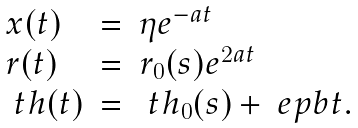<formula> <loc_0><loc_0><loc_500><loc_500>\begin{array} { l l l } x ( t ) & = & \eta e ^ { - a t } \\ r ( t ) & = & r _ { 0 } ( s ) e ^ { 2 a t } \\ \ t h ( t ) & = & \ t h _ { 0 } ( s ) + \ e p b t . \end{array}</formula> 